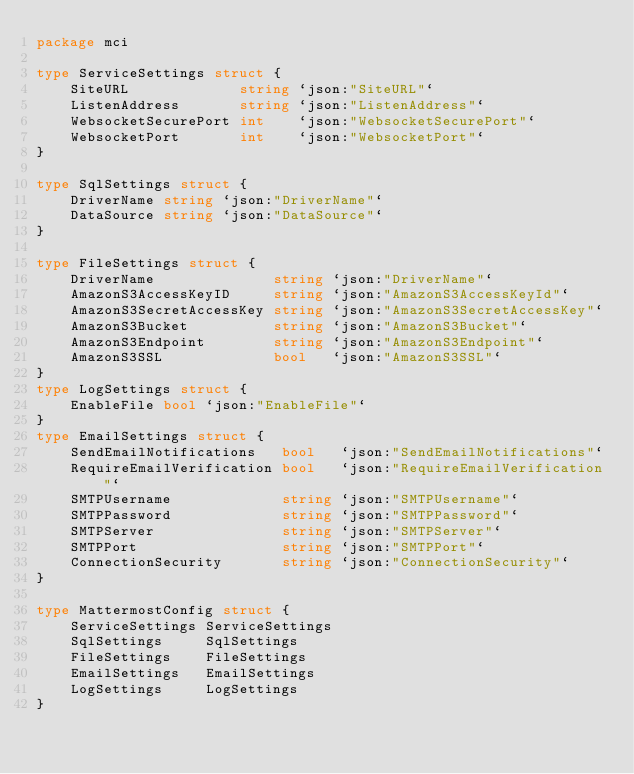Convert code to text. <code><loc_0><loc_0><loc_500><loc_500><_Go_>package mci

type ServiceSettings struct {
	SiteURL             string `json:"SiteURL"`
	ListenAddress       string `json:"ListenAddress"`
	WebsocketSecurePort int    `json:"WebsocketSecurePort"`
	WebsocketPort       int    `json:"WebsocketPort"`
}

type SqlSettings struct {
	DriverName string `json:"DriverName"`
	DataSource string `json:"DataSource"`
}

type FileSettings struct {
	DriverName              string `json:"DriverName"`
	AmazonS3AccessKeyID     string `json:"AmazonS3AccessKeyId"`
	AmazonS3SecretAccessKey string `json:"AmazonS3SecretAccessKey"`
	AmazonS3Bucket          string `json:"AmazonS3Bucket"`
	AmazonS3Endpoint        string `json:"AmazonS3Endpoint"`
	AmazonS3SSL             bool   `json:"AmazonS3SSL"`
}
type LogSettings struct {
	EnableFile bool `json:"EnableFile"`
}
type EmailSettings struct {
	SendEmailNotifications   bool   `json:"SendEmailNotifications"`
	RequireEmailVerification bool   `json:"RequireEmailVerification"`
	SMTPUsername             string `json:"SMTPUsername"`
	SMTPPassword             string `json:"SMTPPassword"`
	SMTPServer               string `json:"SMTPServer"`
	SMTPPort                 string `json:"SMTPPort"`
	ConnectionSecurity       string `json:"ConnectionSecurity"`
}

type MattermostConfig struct {
	ServiceSettings ServiceSettings
	SqlSettings     SqlSettings
	FileSettings    FileSettings
	EmailSettings   EmailSettings
	LogSettings     LogSettings
}
</code> 